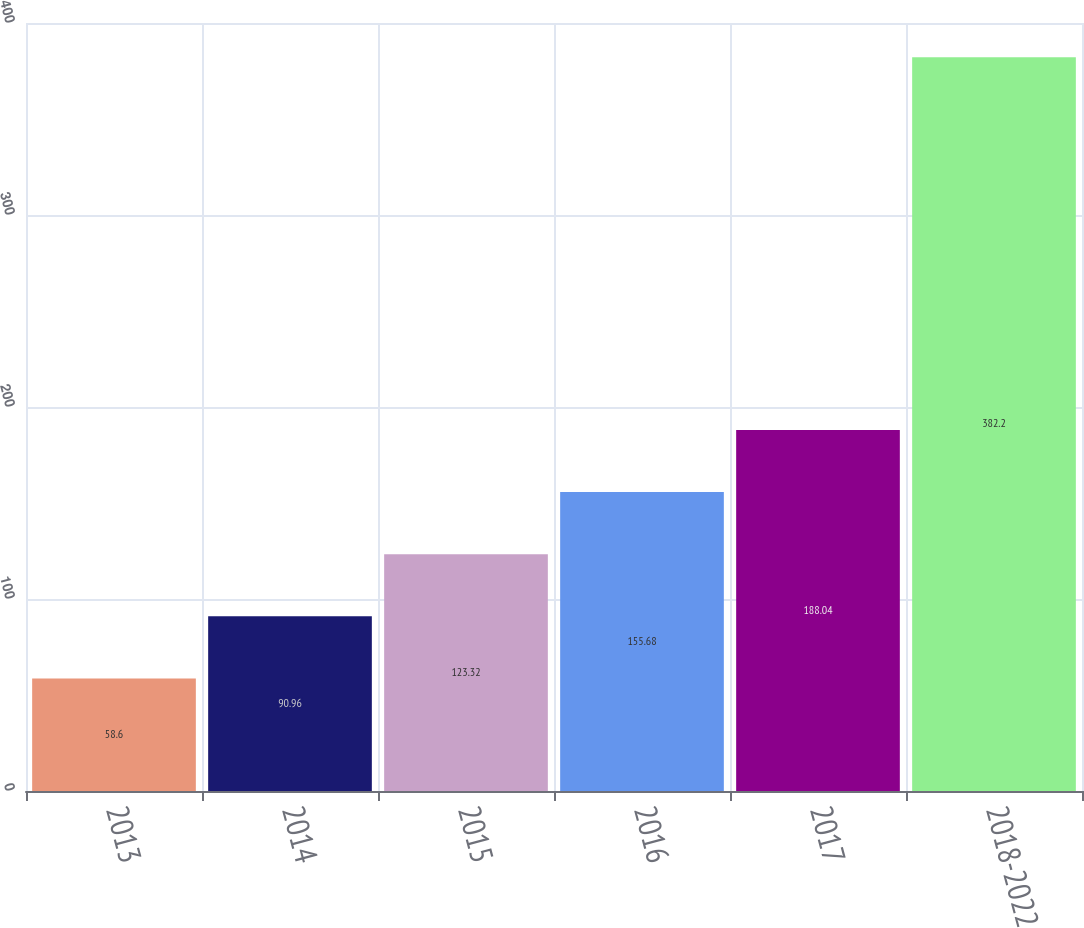<chart> <loc_0><loc_0><loc_500><loc_500><bar_chart><fcel>2013<fcel>2014<fcel>2015<fcel>2016<fcel>2017<fcel>2018-2022<nl><fcel>58.6<fcel>90.96<fcel>123.32<fcel>155.68<fcel>188.04<fcel>382.2<nl></chart> 